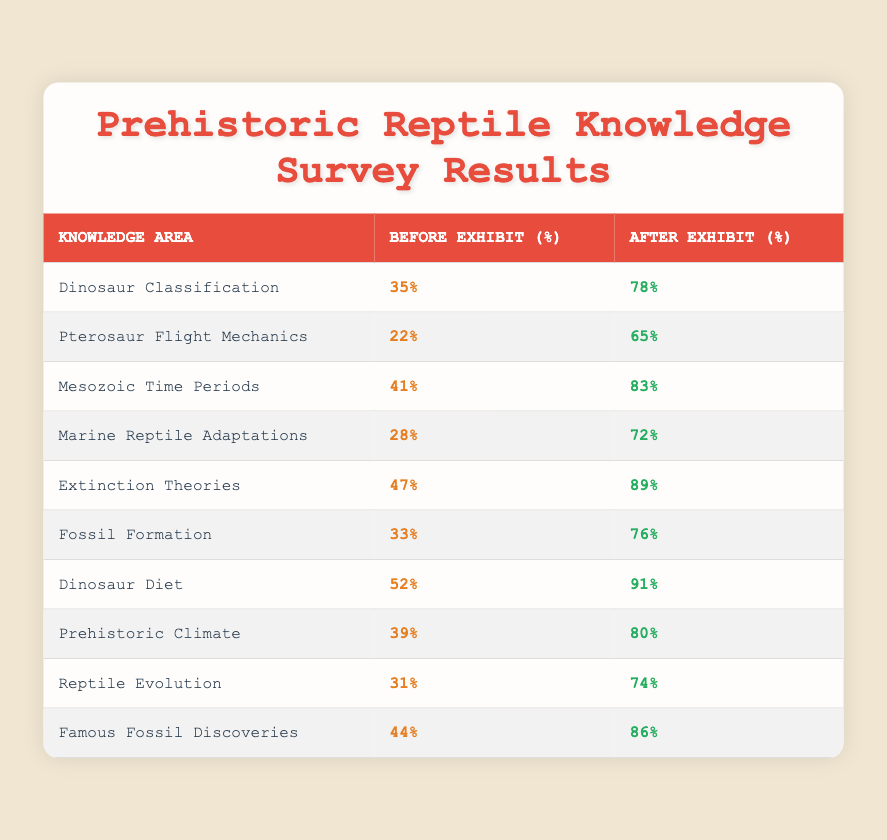What was the percentage increase in understanding of dinosaur classification after the exhibit? The understanding of dinosaur classification increased from 35% to 78%. To find the percentage increase, subtract the before value from the after value: 78% - 35% = 43%.
Answer: 43% What was the before exhibit percentage for marine reptile adaptations? The before exhibit percentage for marine reptile adaptations was 28%, as shown in the table.
Answer: 28% Did more visitors know about extinction theories after the exhibit compared to before? Yes, the percentage of visitors who knew about extinction theories increased from 47% before the exhibit to 89% after the exhibit, indicating more visitors had knowledge after.
Answer: Yes What is the average percentage of knowledge after the exhibit across all knowledge areas? First, sum all the after percentages: 78 + 65 + 83 + 72 + 89 + 76 + 91 + 80 + 74 + 86 =  74.4. Then, divide by the number of areas, which is 10:  74.4 / 10 = 74.4%.
Answer: 74.4% Which knowledge area had the highest percentage increase after the exhibit? By comparing the percentage increases for each knowledge area: Dinosaur Diet had an increase of 39% (from 52% to 91%), which is the highest increase among all areas listed.
Answer: Dinosaur Diet What were the before and after percentages for pterosaur flight mechanics? The before percentage was 22% and the after percentage was 65%, as indicated in the table.
Answer: 22% and 65% Was the understanding of fossil formation lower before or after the exhibit? The understanding of fossil formation was lower before the exhibit, at 33%, compared to 76% after the exhibit, as displayed in the data.
Answer: Before Which knowledge area had a percentage of 80% after the exhibit? The knowledge area that had a percentage of 80% after the exhibit is Prehistoric Climate, as indicated in the table.
Answer: Prehistoric Climate What is the difference in the percentage of knowledge about famous fossil discoveries before and after the exhibit? The percentage for famous fossil discoveries before the exhibit was 44% and after was 86%. To find the difference: 86% - 44% = 42%.
Answer: 42% 